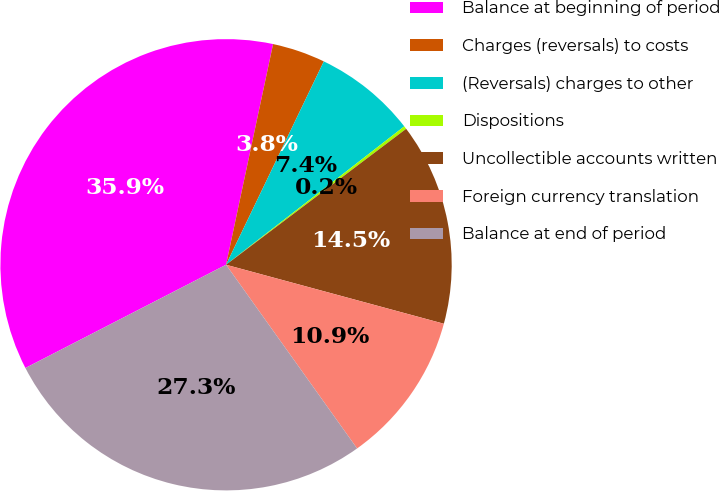Convert chart. <chart><loc_0><loc_0><loc_500><loc_500><pie_chart><fcel>Balance at beginning of period<fcel>Charges (reversals) to costs<fcel>(Reversals) charges to other<fcel>Dispositions<fcel>Uncollectible accounts written<fcel>Foreign currency translation<fcel>Balance at end of period<nl><fcel>35.91%<fcel>3.79%<fcel>7.36%<fcel>0.22%<fcel>14.5%<fcel>10.93%<fcel>27.3%<nl></chart> 